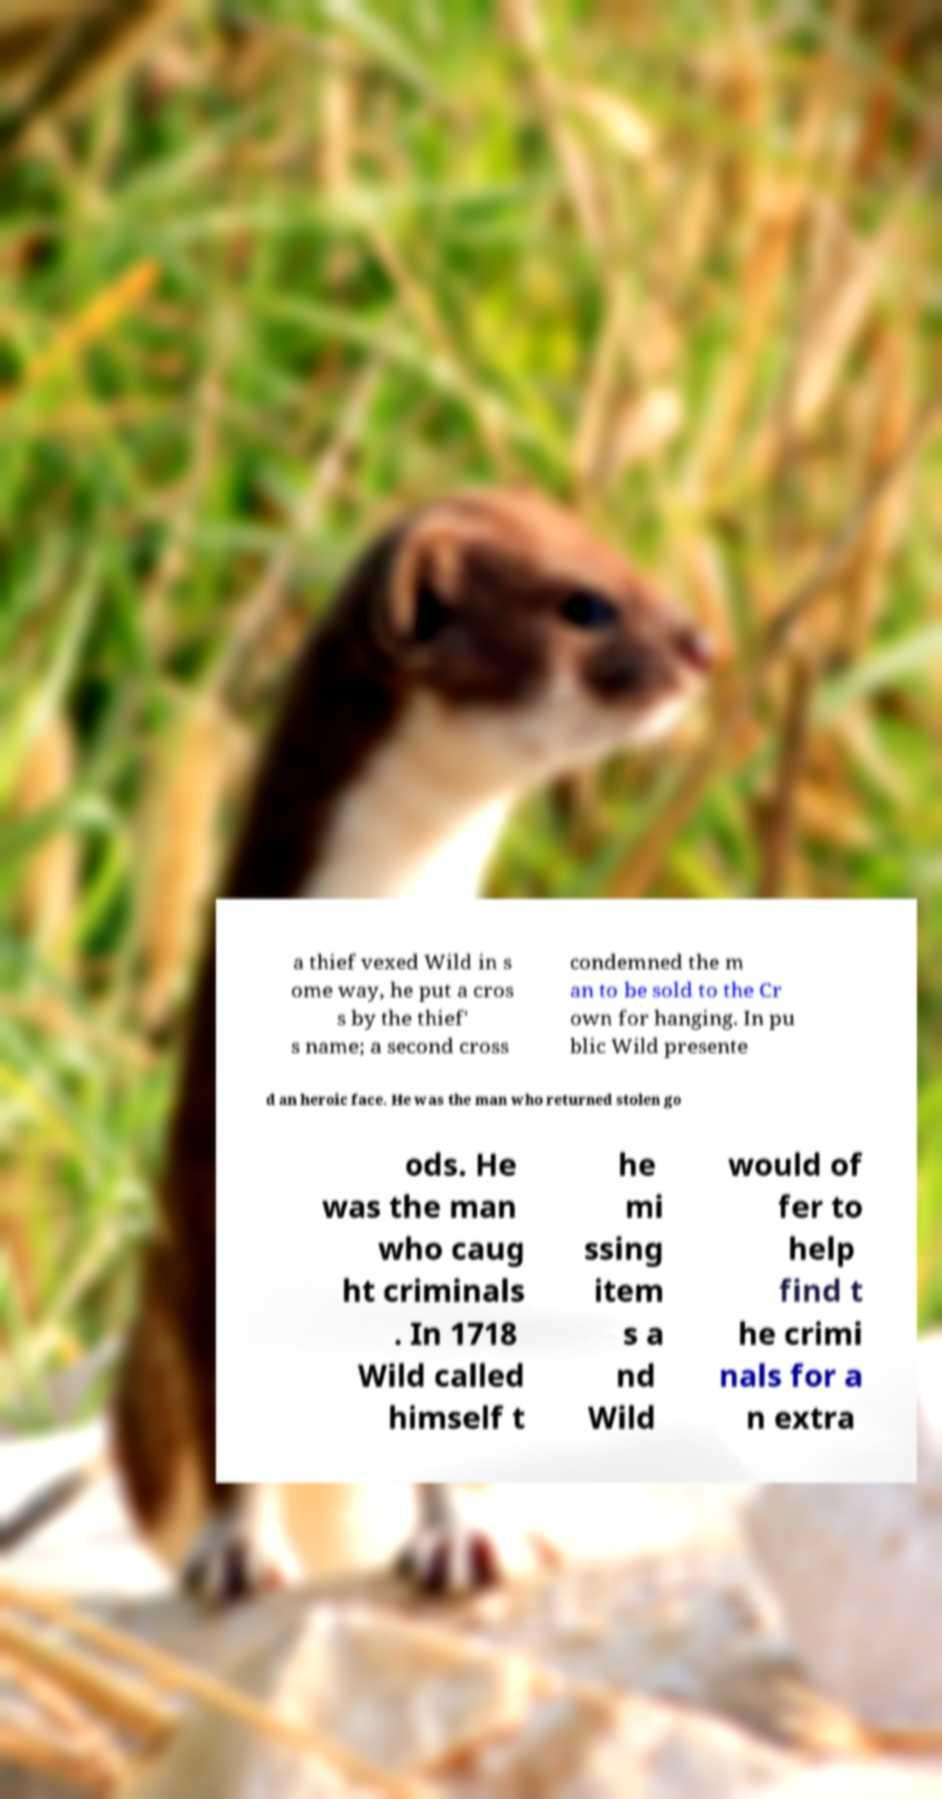What messages or text are displayed in this image? I need them in a readable, typed format. a thief vexed Wild in s ome way, he put a cros s by the thief' s name; a second cross condemned the m an to be sold to the Cr own for hanging. In pu blic Wild presente d an heroic face. He was the man who returned stolen go ods. He was the man who caug ht criminals . In 1718 Wild called himself t he mi ssing item s a nd Wild would of fer to help find t he crimi nals for a n extra 